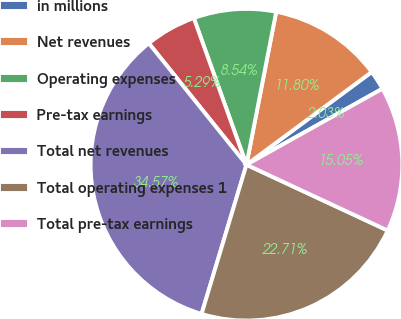Convert chart. <chart><loc_0><loc_0><loc_500><loc_500><pie_chart><fcel>in millions<fcel>Net revenues<fcel>Operating expenses<fcel>Pre-tax earnings<fcel>Total net revenues<fcel>Total operating expenses 1<fcel>Total pre-tax earnings<nl><fcel>2.03%<fcel>11.8%<fcel>8.54%<fcel>5.29%<fcel>34.57%<fcel>22.71%<fcel>15.05%<nl></chart> 